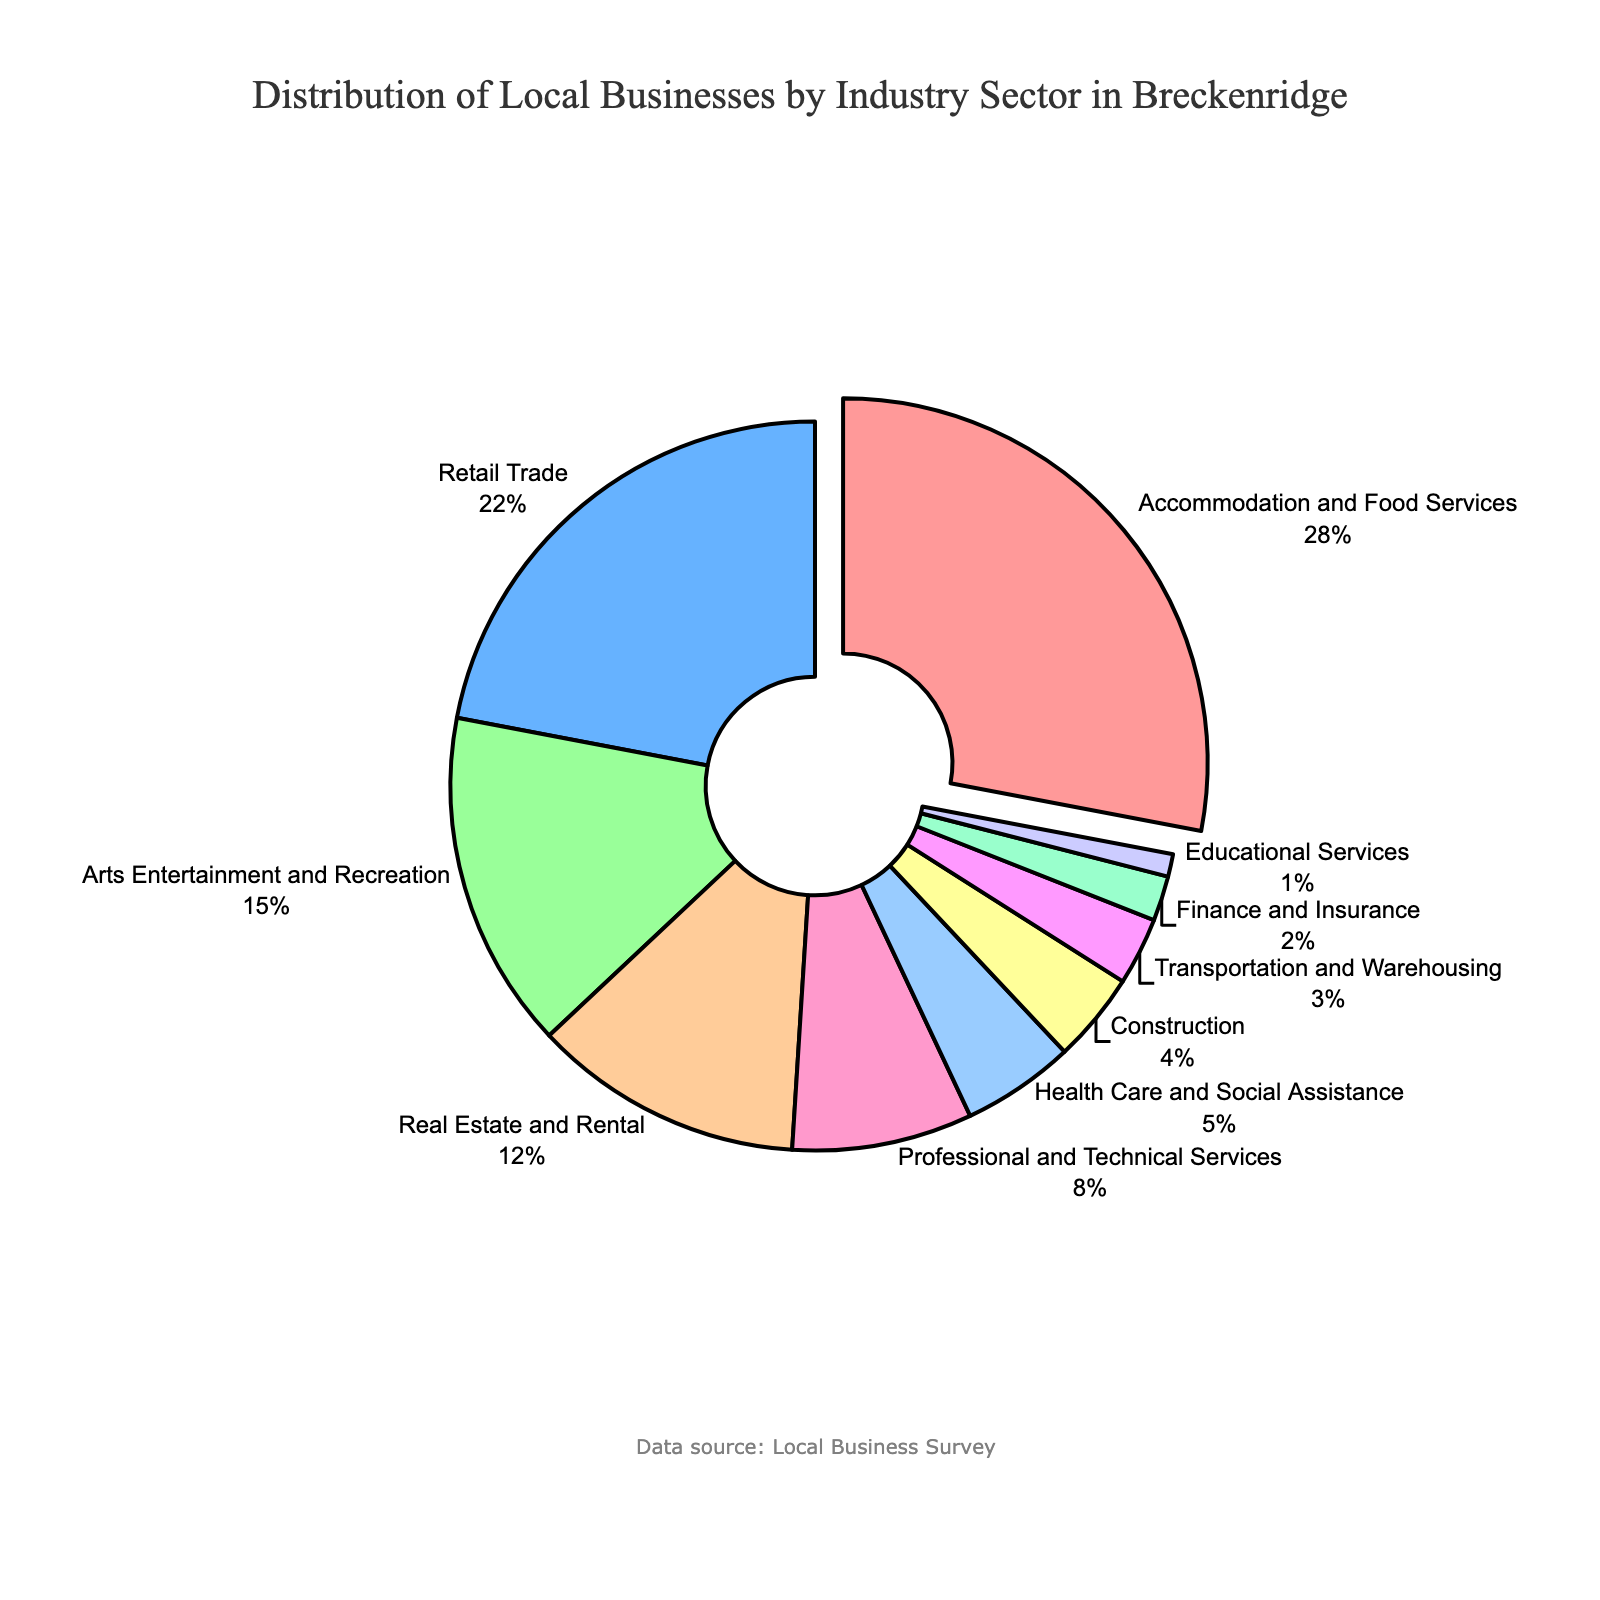What industry sector has the largest share of local businesses in Breckenridge? By looking at the pie chart, the largest segment is visually highlighted and labeled as "Accommodation and Food Services," which accounts for 28% of local businesses.
Answer: Accommodation and Food Services Which industry sector has a smaller share of local businesses, Health Care and Social Assistance or Construction? By examining the pie chart, Health Care and Social Assistance has a slightly larger share at 5% compared to Construction, which has a share of 4%.
Answer: Construction What is the combined percentage of local businesses in the sectors "Real Estate and Rental", "Professional and Technical Services", and "Health Care and Social Assistance"? Looking at the pie chart, the percentages for these sectors are: Real Estate and Rental (12%), Professional and Technical Services (8%), and Health Care and Social Assistance (5%). Summing these up, 12% + 8% + 5% = 25%.
Answer: 25% How much larger is the share of "Retail Trade" businesses compared to "Educational Services" businesses? Retail Trade businesses account for 22% while Educational Services account for 1%. To find the difference, subtract the smaller percentage from the larger one: 22% - 1% = 21%.
Answer: 21% Which two industry sectors combined have a share equal to the "Accommodation and Food Services" sector? The share of Accommodation and Food Services is 28%. The combination of "Real Estate and Rental" (12%) and "Retail Trade" (22%) adds up to 34%, which is not a match. But "Retail Trade" (22%) and "Arts Entertainment and Recreation" (15%) add up to 37%, which is also not a match. The combination that matches exactly is "Retail Trade" and "Construction": 22% + 4% = 26% (Retail Trade and Arts Entertainment and Recreation is closest).
Answer: None combine exactly, but Retail Trade and Construction come close at 26% What is the second most represented industry sector in Breckenridge? From the pie chart, the second largest segment after "Accommodation and Food Services" (28%) is "Retail Trade" with 22%.
Answer: Retail Trade Which sector is represented by the color most similar to green? By visually examining the pie chart and colors used, the sector represented by the most greenish color (light green) is "Arts Entertainment and Recreation".
Answer: Arts Entertainment and Recreation What percentage do the least represented three industry sectors contribute together? The three least represented sectors are "Transportation and Warehousing" (3%), "Finance and Insurance" (2%), and "Educational Services" (1%). Summing these percentages, 3% + 2% + 1% = 6%.
Answer: 6% 